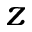<formula> <loc_0><loc_0><loc_500><loc_500>z</formula> 